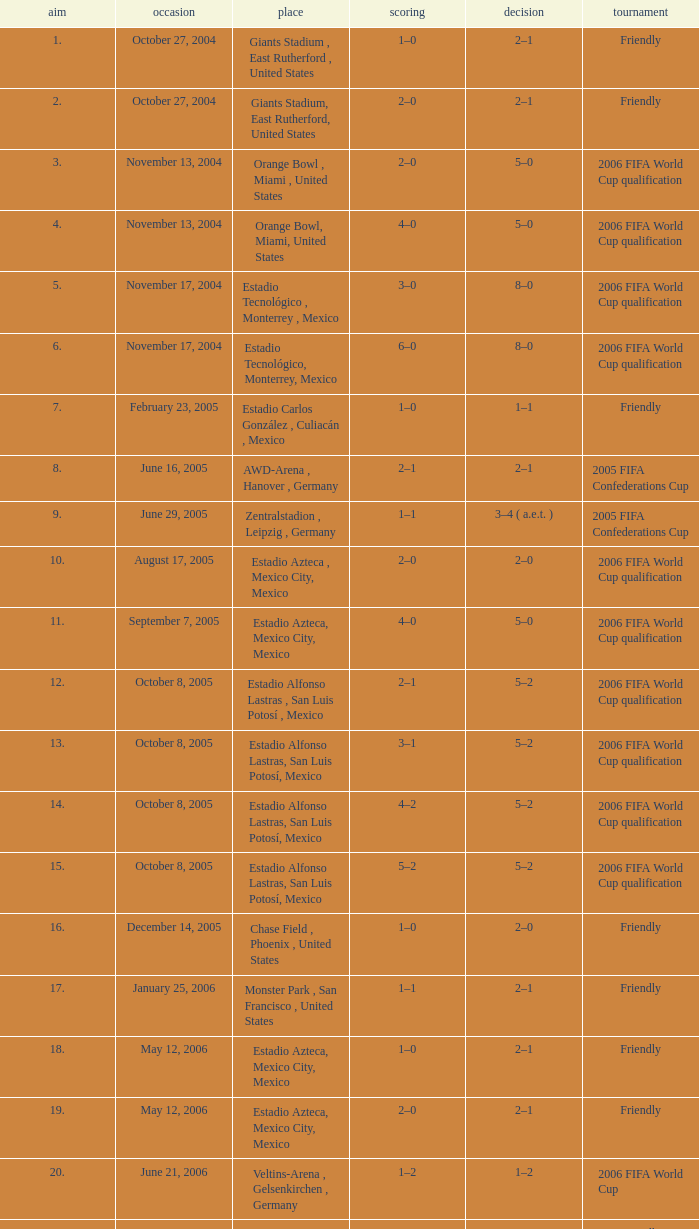Which Score has a Date of october 8, 2005, and a Venue of estadio alfonso lastras, san luis potosí, mexico? 2–1, 3–1, 4–2, 5–2. 